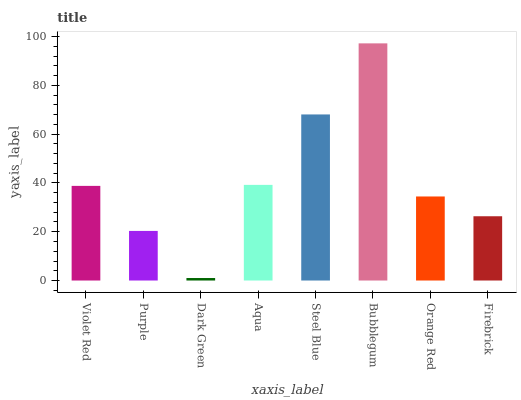Is Dark Green the minimum?
Answer yes or no. Yes. Is Bubblegum the maximum?
Answer yes or no. Yes. Is Purple the minimum?
Answer yes or no. No. Is Purple the maximum?
Answer yes or no. No. Is Violet Red greater than Purple?
Answer yes or no. Yes. Is Purple less than Violet Red?
Answer yes or no. Yes. Is Purple greater than Violet Red?
Answer yes or no. No. Is Violet Red less than Purple?
Answer yes or no. No. Is Violet Red the high median?
Answer yes or no. Yes. Is Orange Red the low median?
Answer yes or no. Yes. Is Dark Green the high median?
Answer yes or no. No. Is Violet Red the low median?
Answer yes or no. No. 